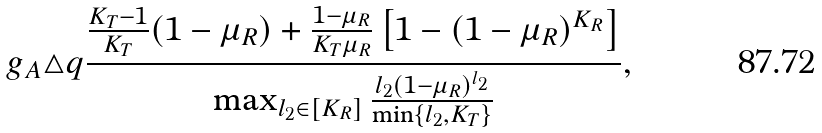<formula> <loc_0><loc_0><loc_500><loc_500>g _ { A } \triangle q \frac { \frac { K _ { T } - 1 } { K _ { T } } ( 1 - \mu _ { R } ) + \frac { 1 - \mu _ { R } } { K _ { T } \mu _ { R } } \left [ 1 - ( 1 - \mu _ { R } ) ^ { K _ { R } } \right ] } { \max _ { l _ { 2 } \in [ K _ { R } ] } \frac { l _ { 2 } ( 1 - \mu _ { R } ) ^ { l _ { 2 } } } { \min \{ l _ { 2 } , K _ { T } \} } } ,</formula> 